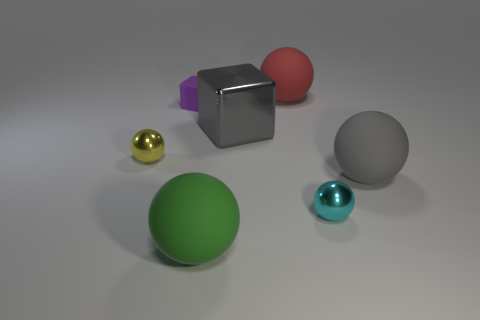What material is the big object that is the same color as the large block?
Ensure brevity in your answer.  Rubber. There is a yellow ball that is the same size as the cyan metallic ball; what material is it?
Your response must be concise. Metal. What is the shape of the cyan metallic object that is the same size as the purple object?
Your answer should be compact. Sphere. There is a gray thing that is to the left of the small object that is to the right of the green matte object that is to the left of the large metallic object; what shape is it?
Provide a succinct answer. Cube. The gray thing that is to the right of the shiny ball that is in front of the tiny yellow shiny object is made of what material?
Your answer should be compact. Rubber. What is the shape of the big gray thing that is made of the same material as the tiny yellow thing?
Offer a terse response. Cube. Are there any other things that have the same shape as the green rubber object?
Offer a very short reply. Yes. There is a large green matte sphere; what number of cyan metal balls are left of it?
Offer a terse response. 0. Is there a tiny red matte sphere?
Offer a very short reply. No. What is the color of the tiny ball that is to the left of the gray object that is behind the metallic object that is left of the large metallic object?
Provide a succinct answer. Yellow. 